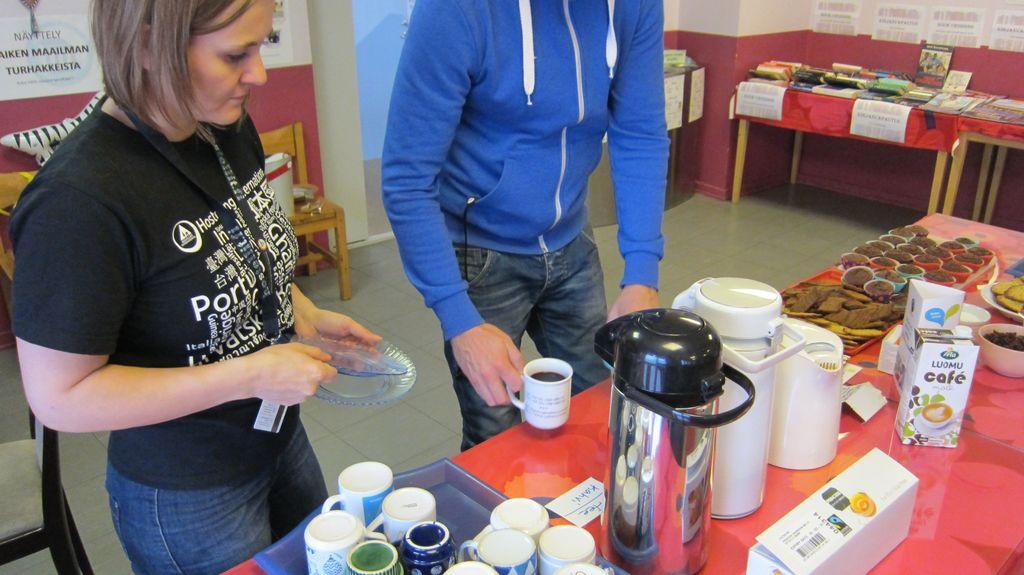What type of creamer are they using?
Offer a terse response. Cafe. 